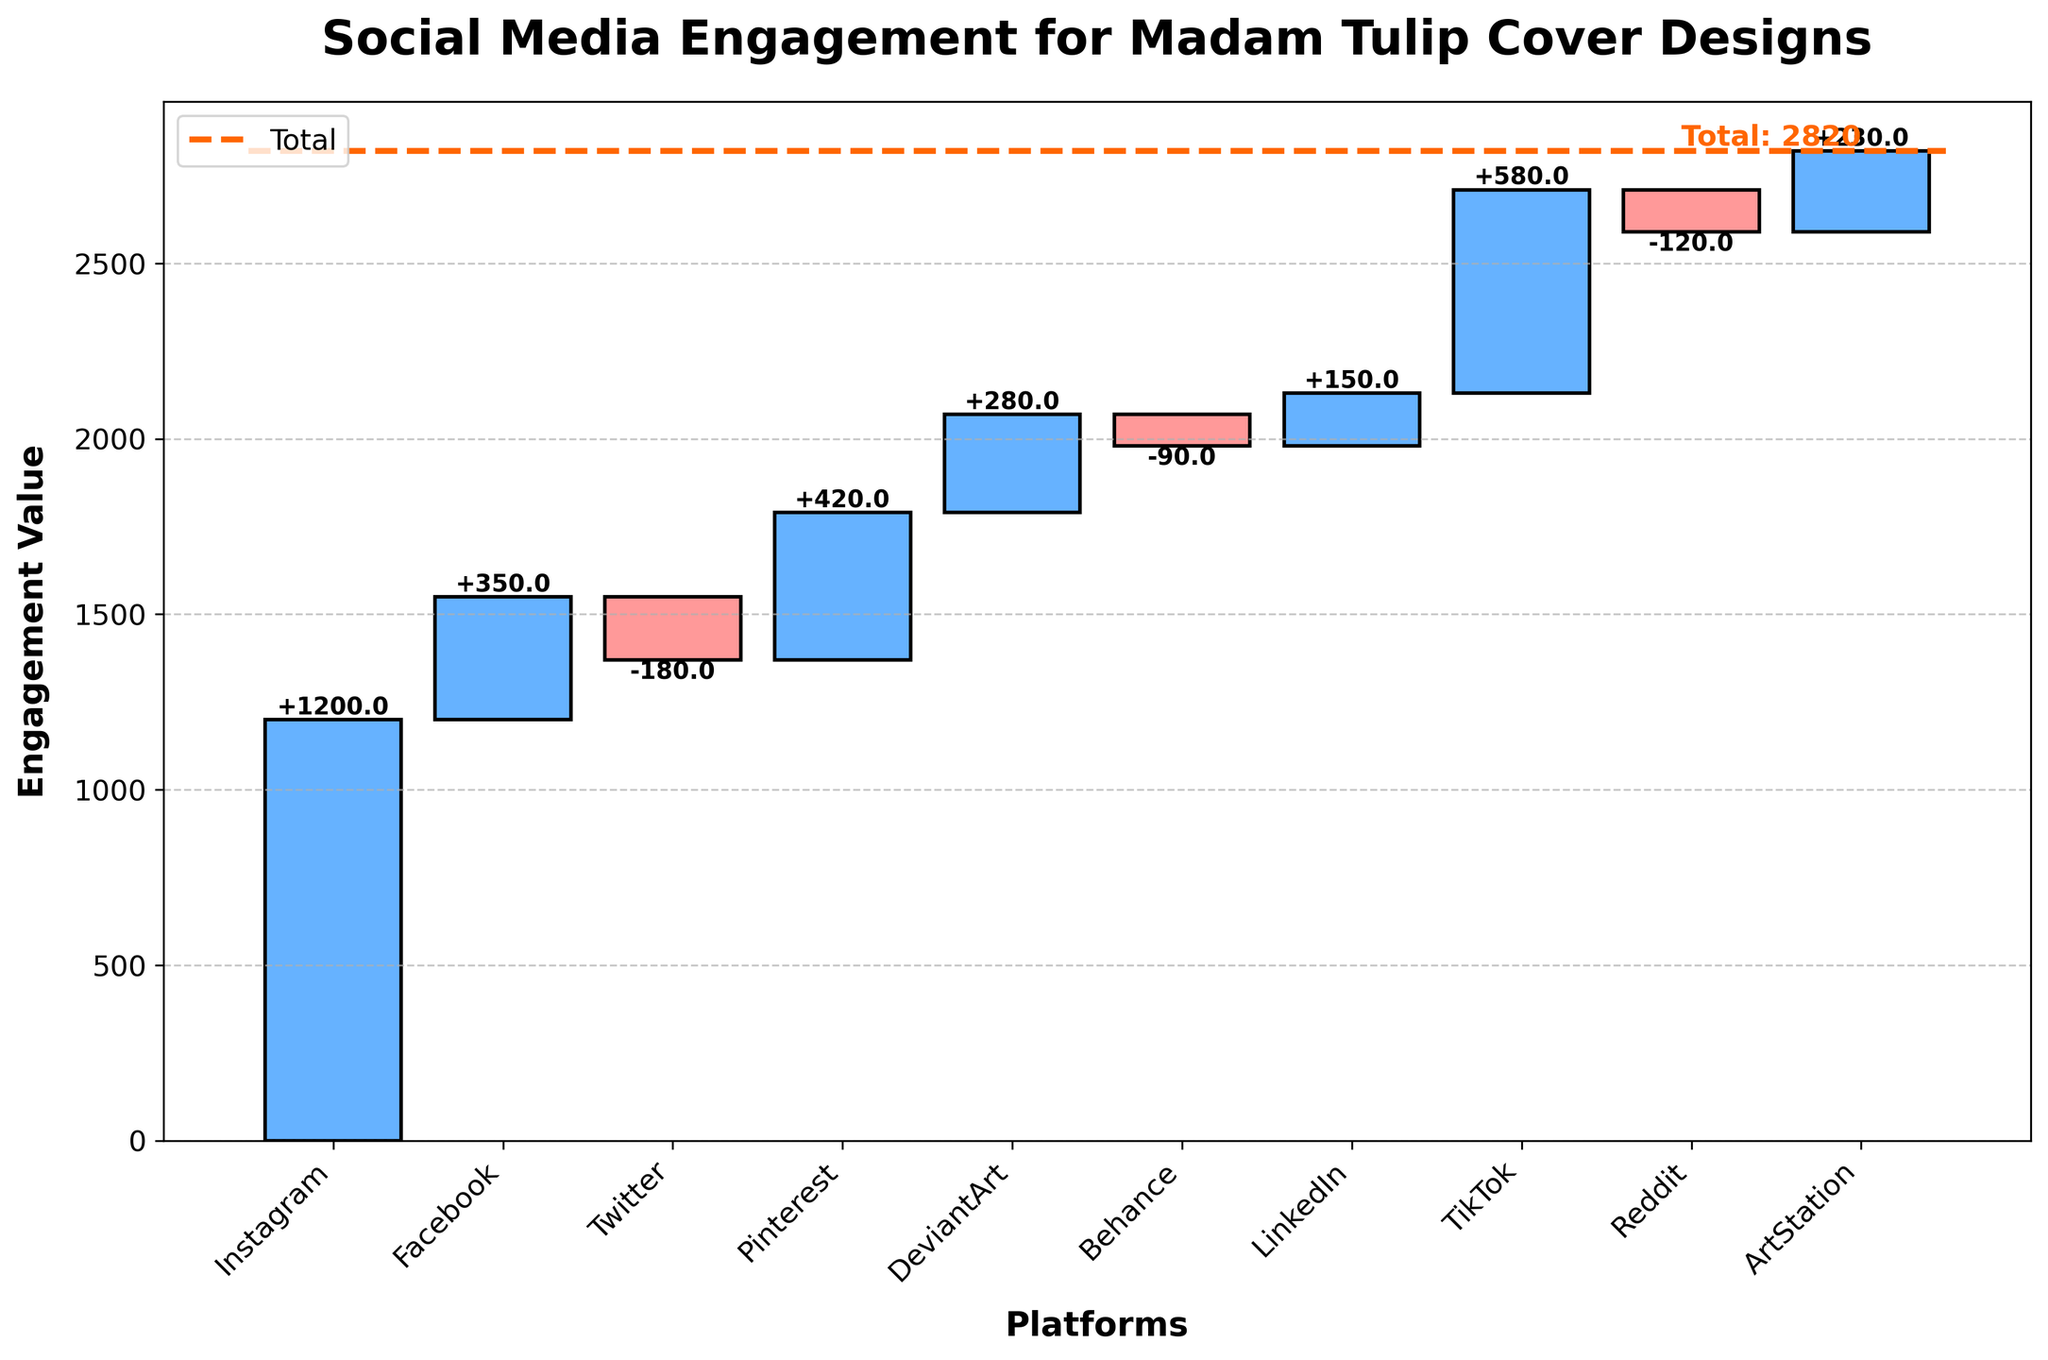What is the title of the chart? The title is typically located at the top of the chart. It provides a concise description of what the chart represents.
Answer: Social Media Engagement for Madam Tulip Cover Designs Which platform had the highest increase in engagement? This can be observed by looking for the tallest positive bar (above the x-axis) in the chart.
Answer: TikTok What is the total engagement value after considering all the platforms? The total engagement value is often labeled at the end or indicated with a line.
Answer: 2820 Which platforms resulted in a decrease in engagement? Decrease in engagement is represented by bars below the x-axis.
Answer: Twitter, Behance, Reddit How does Pinterest's increase in engagement compare to DeviantArt's? Compare the height of the bars corresponding to Pinterest and DeviantArt.
Answer: Pinterest's increase is higher Which platform had the smallest increase in engagement? Look for the shortest positive bar (above the x-axis).
Answer: LinkedIn What would the total be without Twitter and Reddit? Subtract the decreases from Twitter and Reddit from the total. 2820 - (-180) - (-120) = 2820 + 180 + 120
Answer: 3120 What color represents increases in engagement? Observe the color coding of bars that extend above the x-axis.
Answer: Blue 